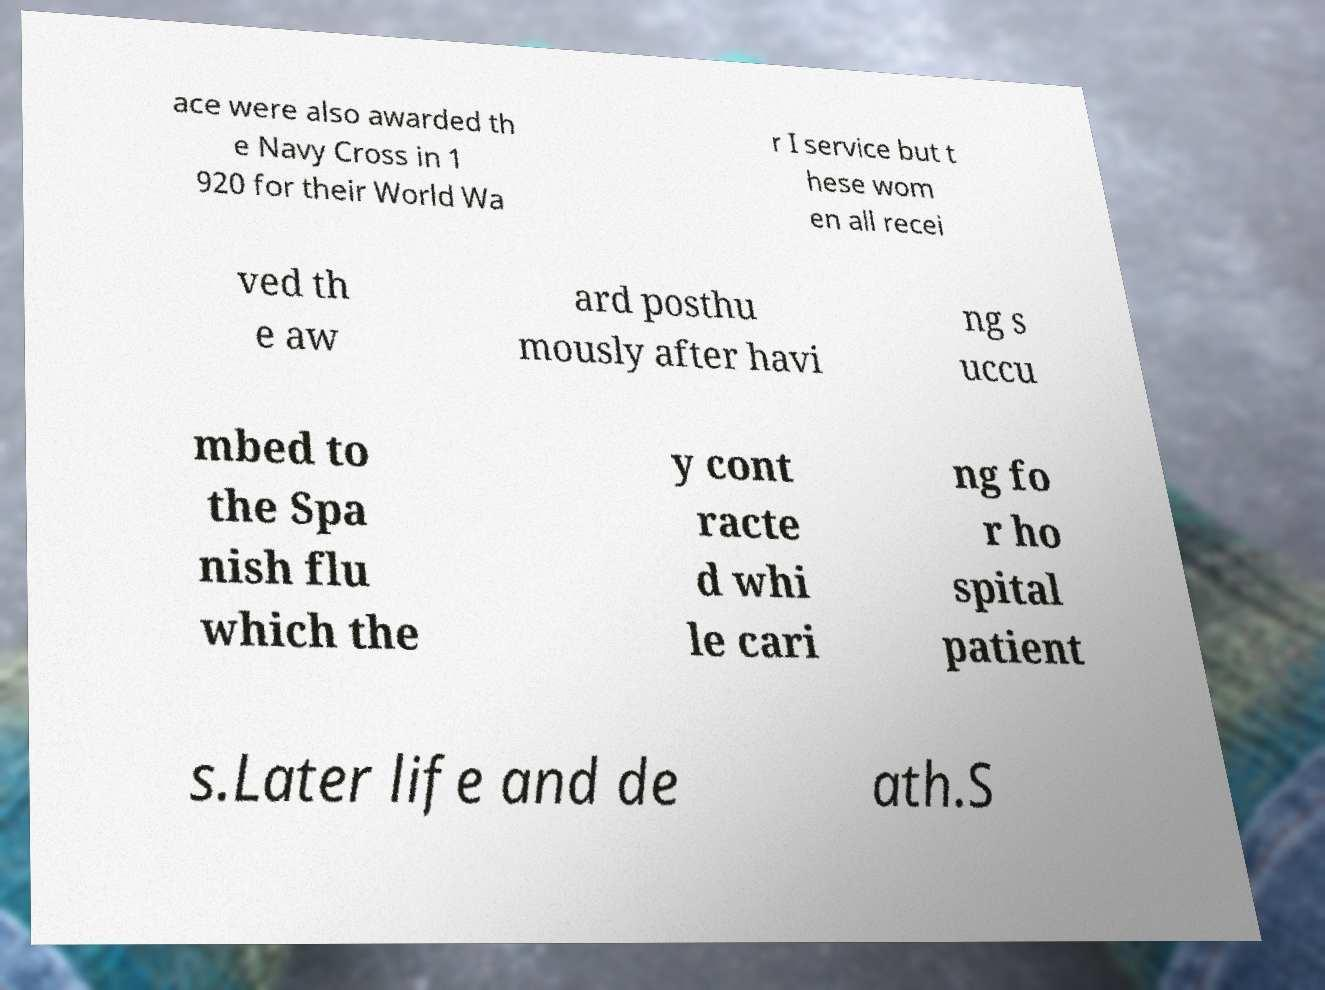Can you read and provide the text displayed in the image?This photo seems to have some interesting text. Can you extract and type it out for me? ace were also awarded th e Navy Cross in 1 920 for their World Wa r I service but t hese wom en all recei ved th e aw ard posthu mously after havi ng s uccu mbed to the Spa nish flu which the y cont racte d whi le cari ng fo r ho spital patient s.Later life and de ath.S 